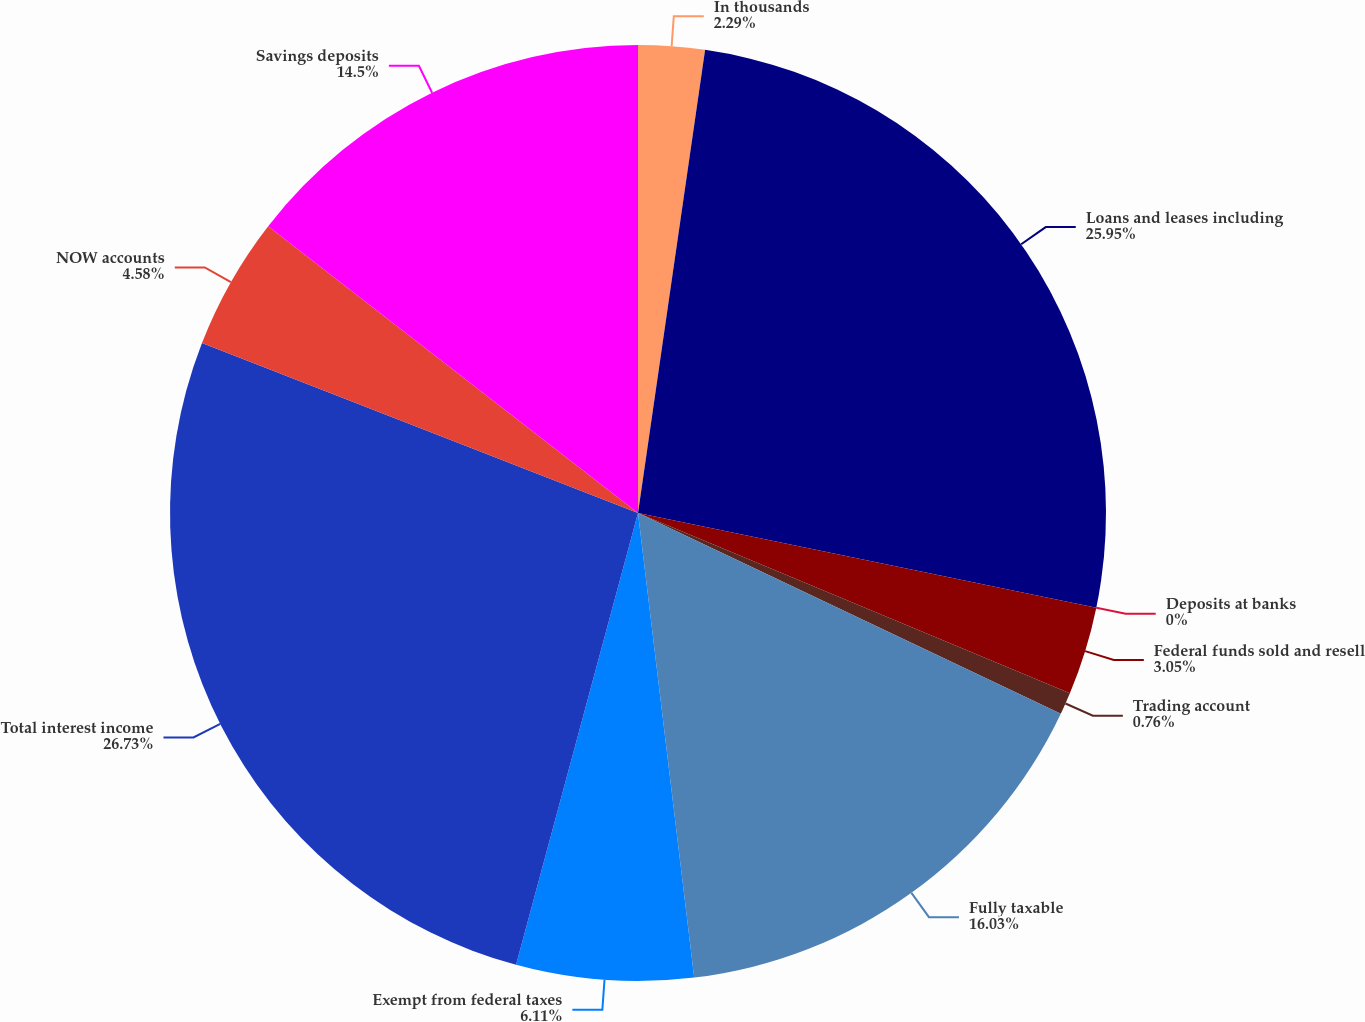Convert chart to OTSL. <chart><loc_0><loc_0><loc_500><loc_500><pie_chart><fcel>In thousands<fcel>Loans and leases including<fcel>Deposits at banks<fcel>Federal funds sold and resell<fcel>Trading account<fcel>Fully taxable<fcel>Exempt from federal taxes<fcel>Total interest income<fcel>NOW accounts<fcel>Savings deposits<nl><fcel>2.29%<fcel>25.95%<fcel>0.0%<fcel>3.05%<fcel>0.76%<fcel>16.03%<fcel>6.11%<fcel>26.72%<fcel>4.58%<fcel>14.5%<nl></chart> 